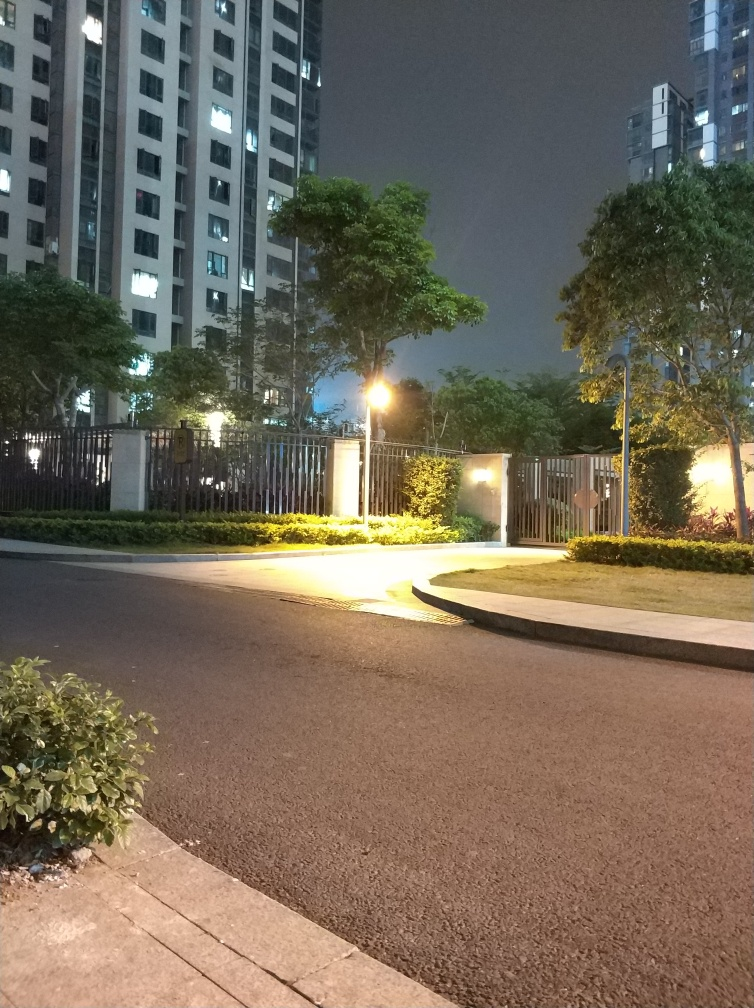Is there any noise present in the image? Upon close examination, the image exhibits a minimal amount of noise which is typical for low-light conditions or high ISO camera settings. While it’s not entirely noise-free, the noise does not significantly detract from the overall clarity of the image. 